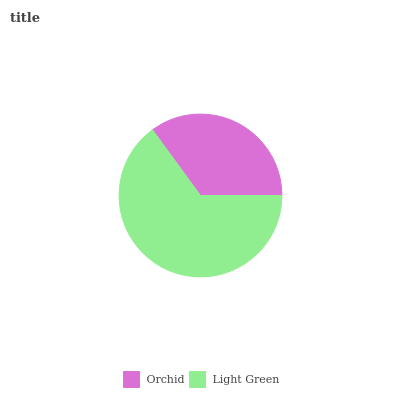Is Orchid the minimum?
Answer yes or no. Yes. Is Light Green the maximum?
Answer yes or no. Yes. Is Light Green the minimum?
Answer yes or no. No. Is Light Green greater than Orchid?
Answer yes or no. Yes. Is Orchid less than Light Green?
Answer yes or no. Yes. Is Orchid greater than Light Green?
Answer yes or no. No. Is Light Green less than Orchid?
Answer yes or no. No. Is Light Green the high median?
Answer yes or no. Yes. Is Orchid the low median?
Answer yes or no. Yes. Is Orchid the high median?
Answer yes or no. No. Is Light Green the low median?
Answer yes or no. No. 